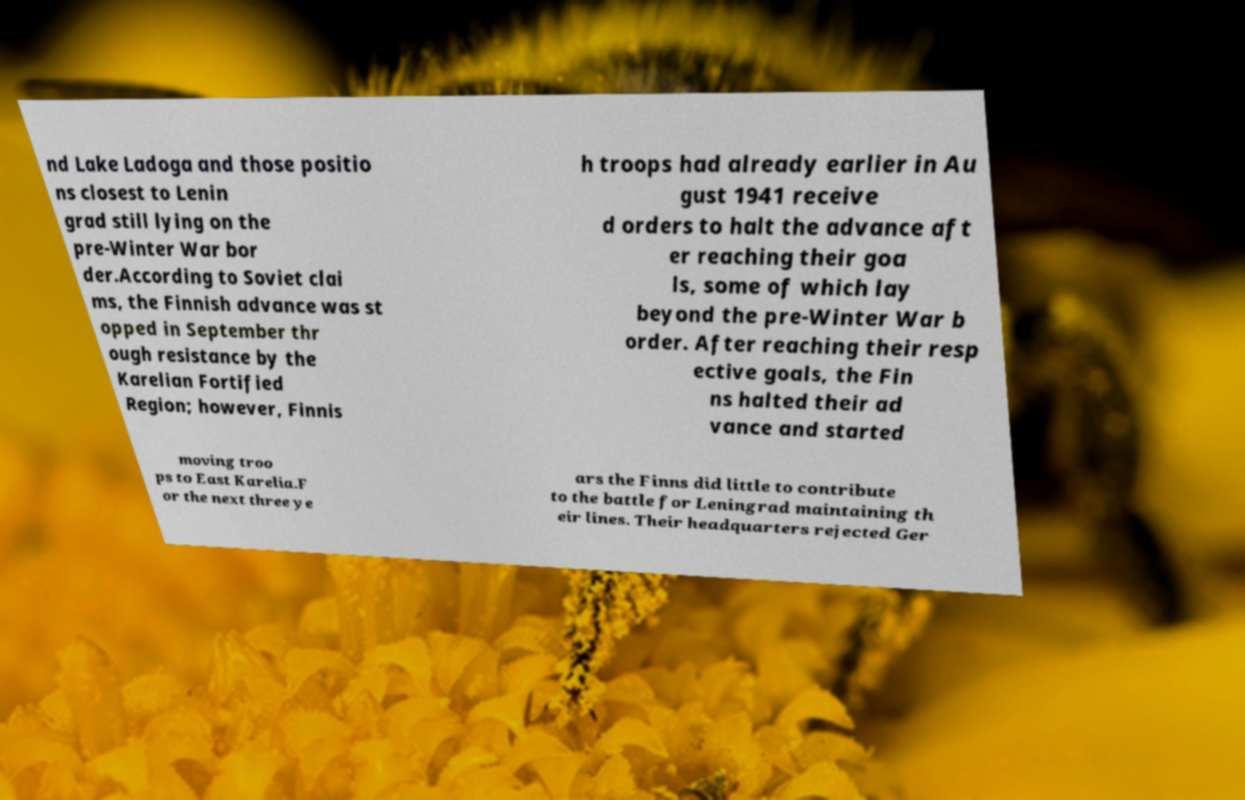Could you extract and type out the text from this image? nd Lake Ladoga and those positio ns closest to Lenin grad still lying on the pre-Winter War bor der.According to Soviet clai ms, the Finnish advance was st opped in September thr ough resistance by the Karelian Fortified Region; however, Finnis h troops had already earlier in Au gust 1941 receive d orders to halt the advance aft er reaching their goa ls, some of which lay beyond the pre-Winter War b order. After reaching their resp ective goals, the Fin ns halted their ad vance and started moving troo ps to East Karelia.F or the next three ye ars the Finns did little to contribute to the battle for Leningrad maintaining th eir lines. Their headquarters rejected Ger 